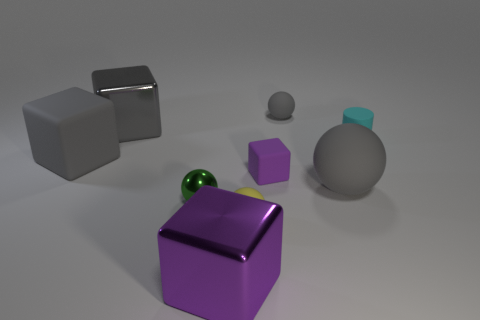The gray block that is the same material as the cyan cylinder is what size?
Give a very brief answer. Large. Do the yellow thing and the purple thing that is in front of the tiny green metal sphere have the same shape?
Your answer should be very brief. No. The gray shiny object has what size?
Keep it short and to the point. Large. Are there fewer gray matte cubes on the right side of the small yellow object than big balls?
Keep it short and to the point. Yes. How many purple blocks have the same size as the yellow object?
Offer a very short reply. 1. What shape is the thing that is the same color as the tiny rubber cube?
Offer a very short reply. Cube. Does the rubber block that is on the left side of the big purple thing have the same color as the metallic cube that is in front of the tiny cyan cylinder?
Provide a short and direct response. No. What number of yellow spheres are left of the tiny gray rubber thing?
Make the answer very short. 1. There is a matte cube that is the same color as the big sphere; what size is it?
Provide a succinct answer. Large. Is there a tiny red object that has the same shape as the tiny green shiny object?
Offer a very short reply. No. 